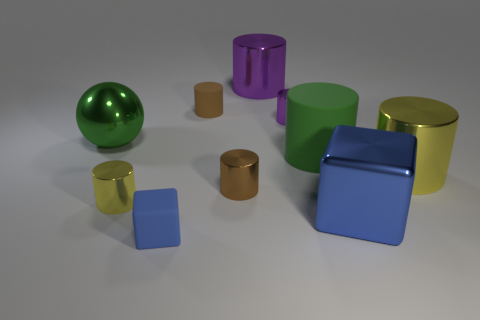Is there any other thing that is the same shape as the green metallic object?
Make the answer very short. No. How big is the purple metallic object that is behind the brown rubber thing?
Give a very brief answer. Large. What number of large yellow matte cubes are there?
Offer a very short reply. 0. How many small objects are behind the yellow cylinder to the left of the big green cylinder?
Your answer should be very brief. 3. Is the color of the small rubber cube the same as the big shiny object in front of the big yellow metallic thing?
Give a very brief answer. Yes. How many big green things have the same shape as the tiny blue object?
Keep it short and to the point. 0. There is a big green object that is to the left of the brown rubber thing; what material is it?
Provide a succinct answer. Metal. There is a yellow shiny thing on the left side of the blue shiny thing; does it have the same shape as the large blue thing?
Offer a terse response. No. Is there a brown sphere that has the same size as the green cylinder?
Provide a succinct answer. No. Do the brown metallic thing and the small shiny object that is behind the metal sphere have the same shape?
Offer a very short reply. Yes. 